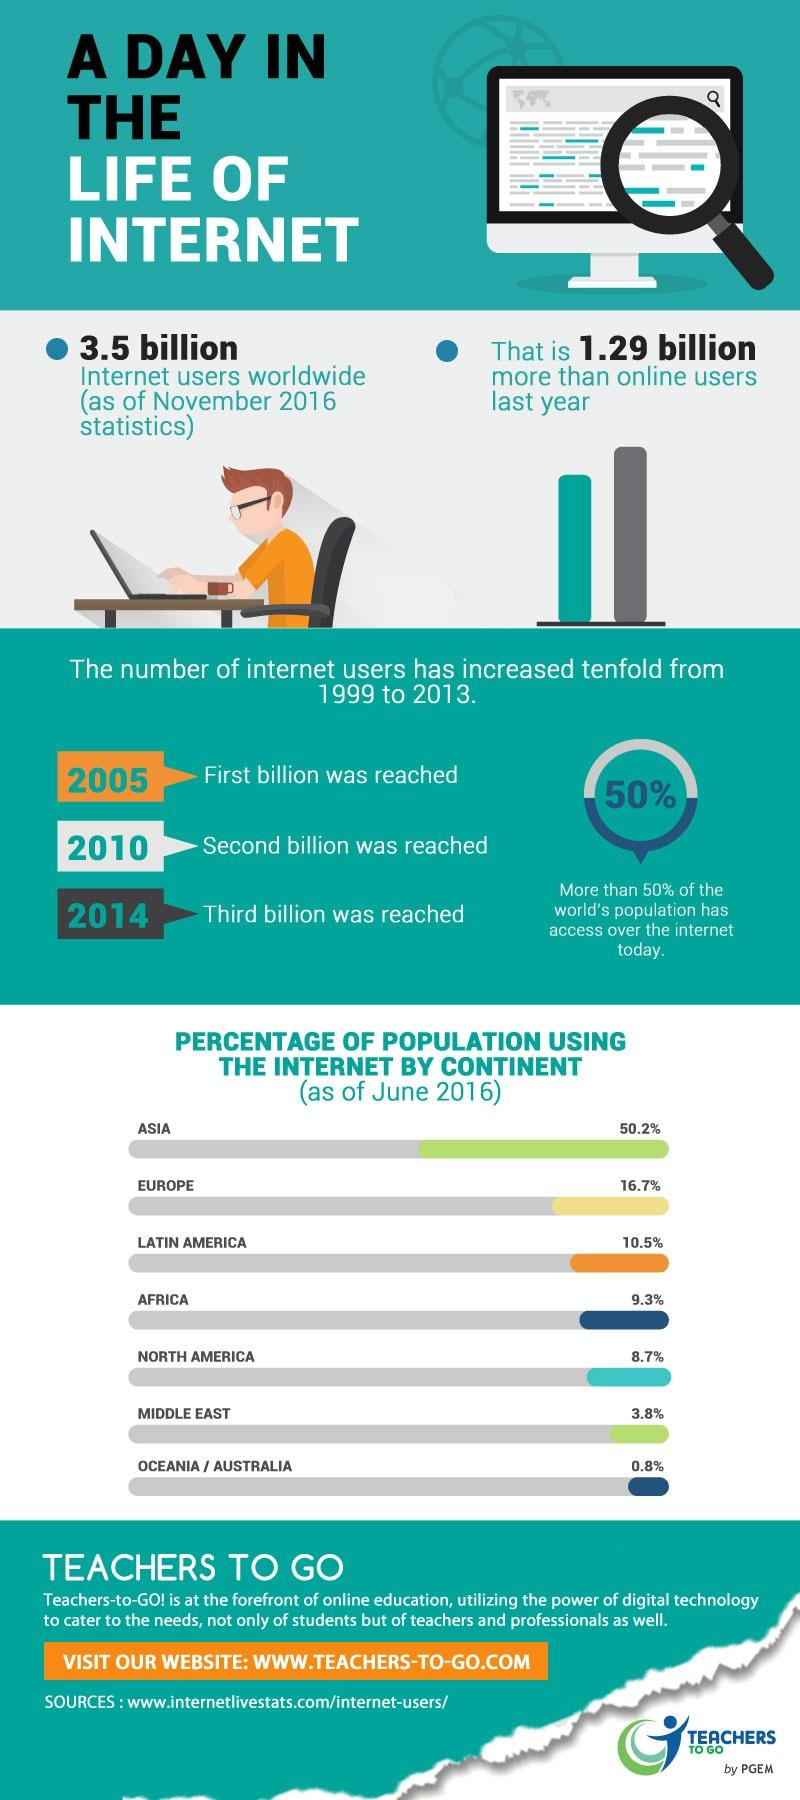Outline some significant characteristics in this image. According to data, approximately 12.5% of the population in the Middle East and North America are using the internet. According to data, approximately 66.9% of the population in Asia and Europe are using the internet. According to a recent study, approximately 19.8% of the population in Latin America and Africa are currently using the internet. It is estimated that only 4.6% of the population in the Middle East and Australia, taken together, are using the internet. A recent estimate indicates that approximately 27.2% of the population in Europe and Latin America are currently using the internet. 